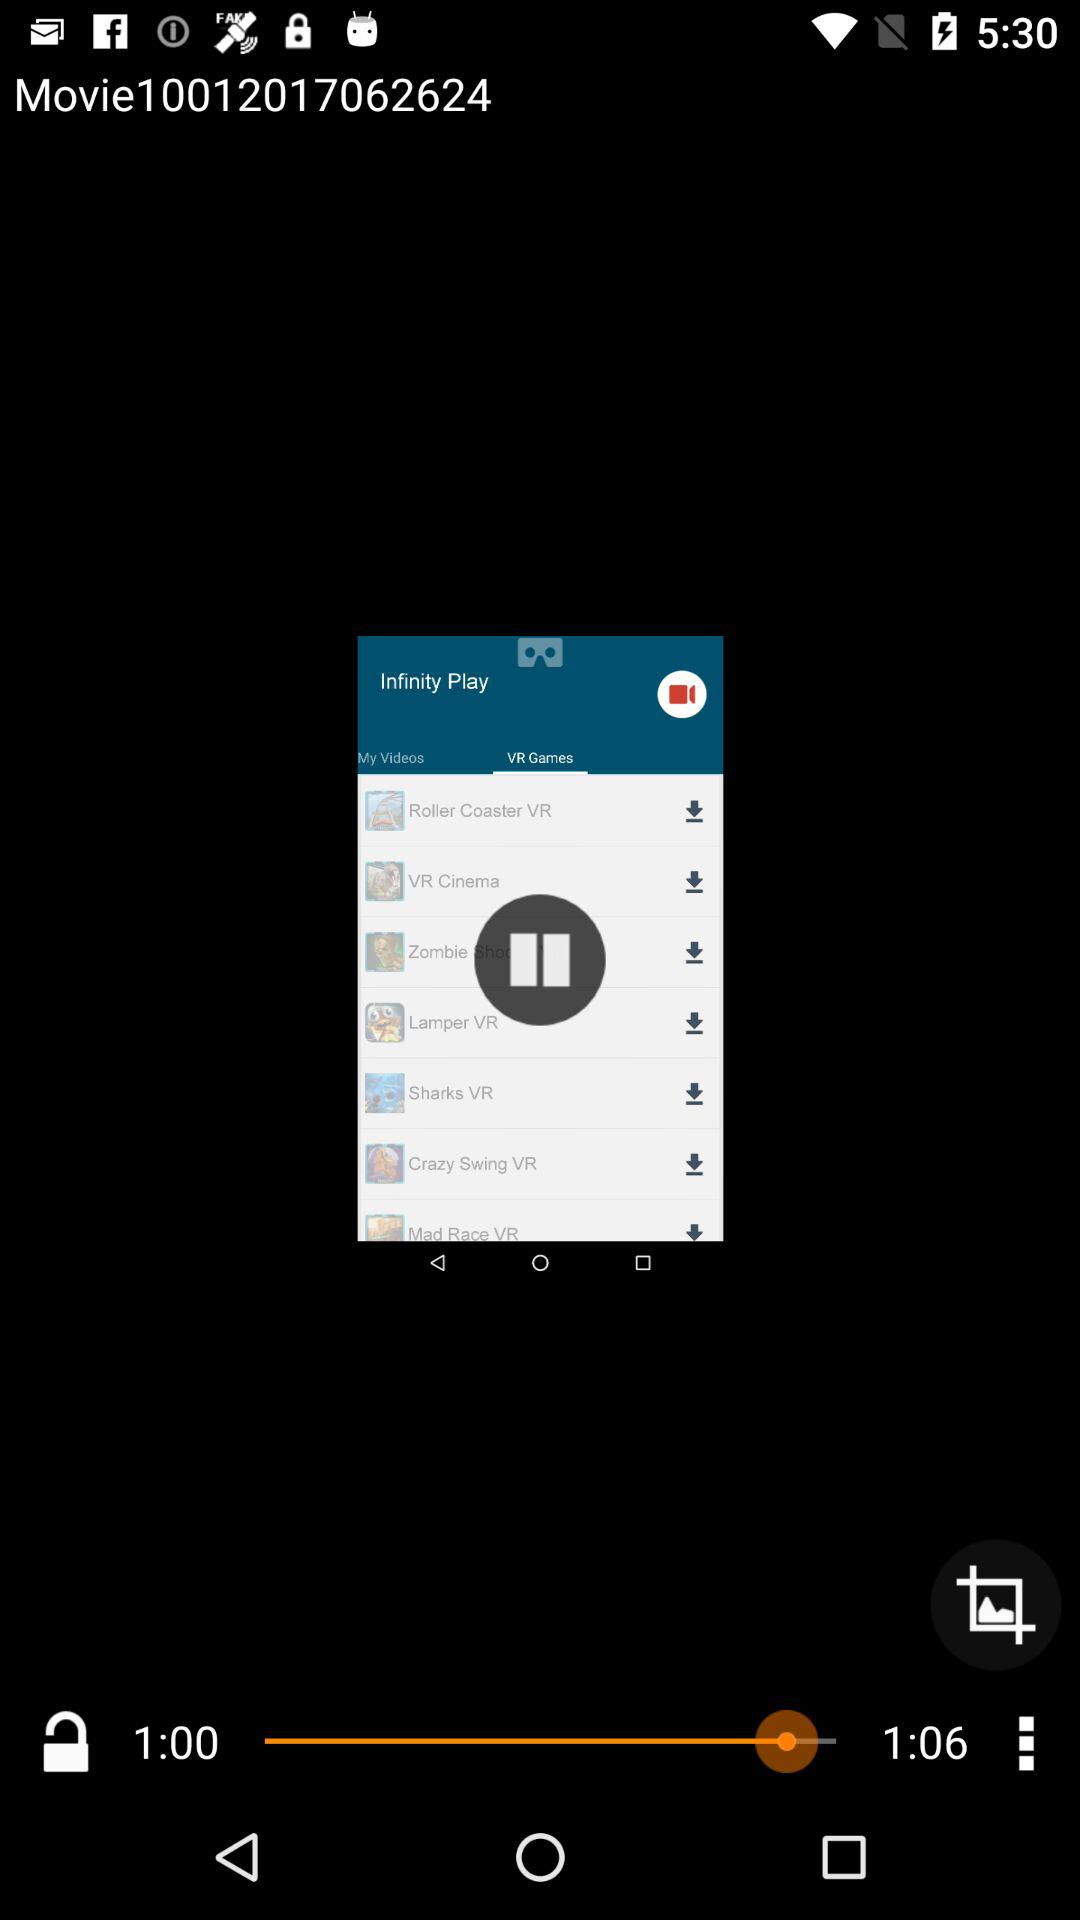How much of the video has been finished? The finished time of the video is 1 minute. 